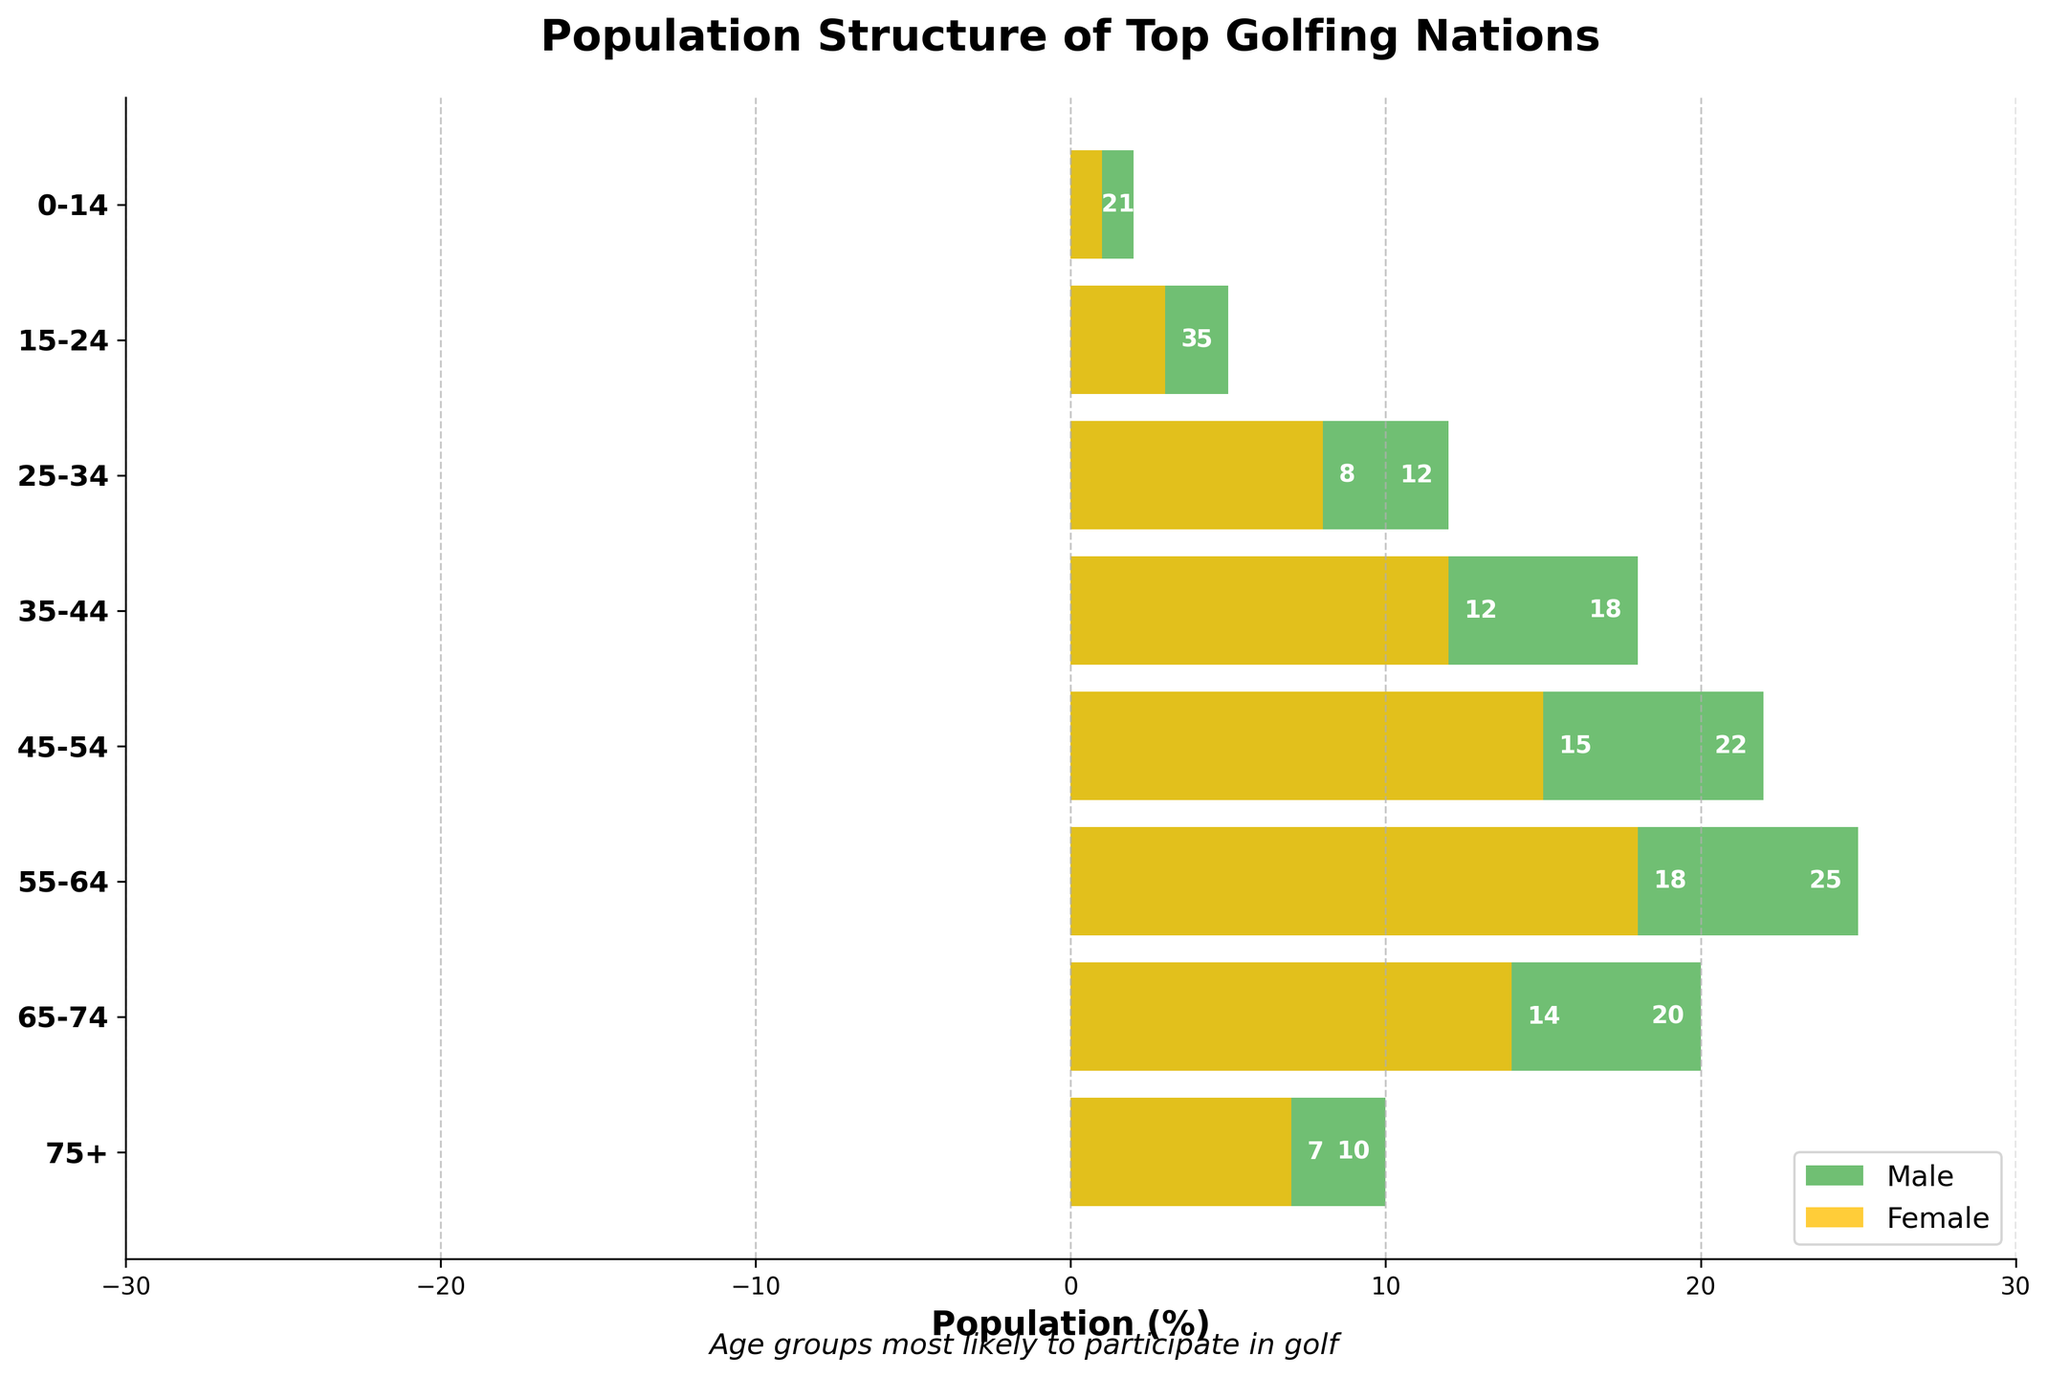Which age group has the highest male population percentage in golfing nations? By looking at the population pyramid, the age group with the longest bar on the male side (left side) indicates the highest male population percentage. The 55-64 age group has the longest male bar, thus the highest percentage.
Answer: 55-64 Which age group has the highest female population percentage in golfing nations? Similar to the male percentage, by examining the bars on the female side, the age group with the longest bar is the 55-64 group.
Answer: 55-64 How does the 35-44 male population percentage compare to the 35-44 female population percentage? The male bar for the 35-44 age group extends to -18%, while the female bar for the same group extends to 12%. By comparing these two values, males have a higher percentage compared to females in this age group.
Answer: Males have a higher percentage What is the total population percentage for both males and females in the 25-34 age group? The male population percentage is 12% (considering the absolute value) and the female population percentage is 8%. Adding these together, we get 12% + 8% = 20%.
Answer: 20% Which age group has the smallest difference between male and female population percentages? For each age group, calculate the absolute difference between the male and female percentages. The 0-14 age group has a male population of 2% and a female population of 1%, so the difference is
Answer: 0-14 In which age group is the female population percentage more than double the male population percentage? To find this, we need to identify an age group where the female percentage is more than twice the absolute value of the male percentage. The 0-14 age group has 2% males and 1% females, and the 75+ age group has 10% males and 7% females. All other groups do not meet this criterion.
Answer: None What is the total percentage of the population aged 55+ for both males and females combined? To get the total population aged 55+, sum the population percentages for the age groups 55-64, 65-74, and 75+ for both genders. This results in: -65% for males and 39% for females.
Answer: 104% Are there more males or females in the 45-54 age group? The male bar for 45-54 extends to -22% (absolute value is 22%) and the female bar extends to 15%. Since 22% is greater than 15%, there are more males than females in this age group.
Answer: Males How much greater is the female percentage population in the 75+ age group compared to the male percentage? The female percentage in the 75+ age group is 7% while the male percentage is 10% (absolute). The female percentage is actually less. The difference is -3%.
Answer: 10% greater 